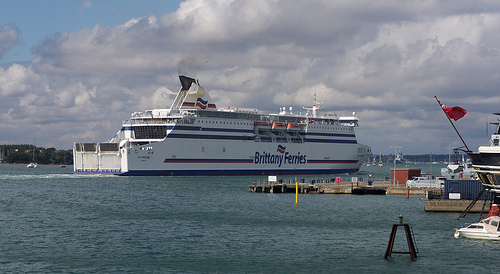Imagine you are a captain looking at this dock. What detailed instructions would you give to your crew for ensuring a safe docking procedure? As the captain, I would instruct the crew to follow these detailed steps for a safe docking procedure:

1. **Approach with Caution**: Slowly reduce speed as we approach the dock, maintaining steady communication with the harbor master.
2. **Prepare the Mooring Lines**: Assign crew members to prepare the mooring lines, ensuring they are ready to be thrown to the dock workers.
3. **Deploy Fenders**: Position fenders along the side of the ship to prevent any damage upon contact with the dock.
4. **Maintain Position**: Use thrusters and rudders to carefully maneuver the ship, keeping it aligned with the docking position. Frequent updates on the ship's speed and alignment should be communicated.
5. **Secure the Lines**: Once the mooring lines have been received by the dock workers, ensure they are properly secured to the bollards, gradually tightening them to secure the ship's positioning.
6. **Engine Cut-off**: Once securely docked, instruct the engine crew to cut off the main engines and switch to auxiliary power.
7. **Safety Checks**: Conduct a thorough inspection of the docking area to ensure all gangways, ramps, and safety equipment are properly positioned for the safe disembarkation of passengers and crew. 